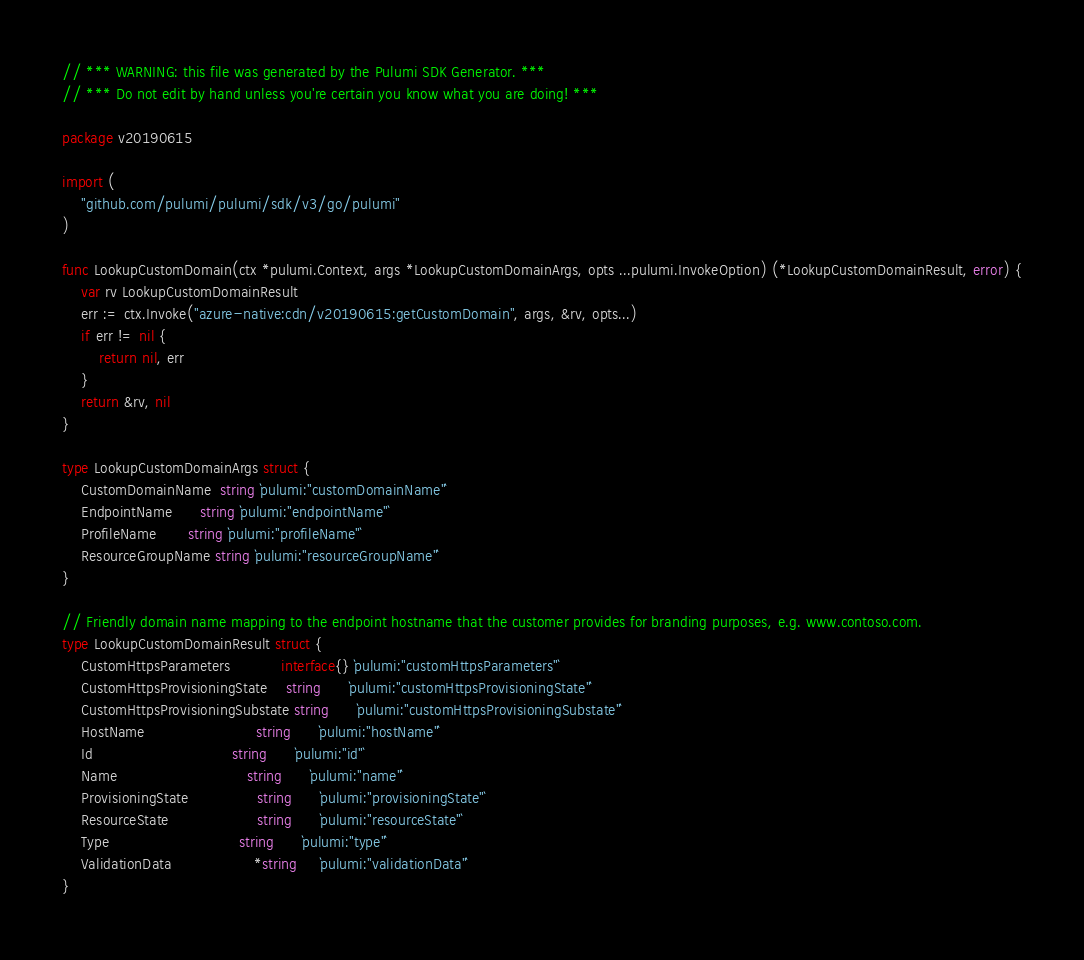Convert code to text. <code><loc_0><loc_0><loc_500><loc_500><_Go_>// *** WARNING: this file was generated by the Pulumi SDK Generator. ***
// *** Do not edit by hand unless you're certain you know what you are doing! ***

package v20190615

import (
	"github.com/pulumi/pulumi/sdk/v3/go/pulumi"
)

func LookupCustomDomain(ctx *pulumi.Context, args *LookupCustomDomainArgs, opts ...pulumi.InvokeOption) (*LookupCustomDomainResult, error) {
	var rv LookupCustomDomainResult
	err := ctx.Invoke("azure-native:cdn/v20190615:getCustomDomain", args, &rv, opts...)
	if err != nil {
		return nil, err
	}
	return &rv, nil
}

type LookupCustomDomainArgs struct {
	CustomDomainName  string `pulumi:"customDomainName"`
	EndpointName      string `pulumi:"endpointName"`
	ProfileName       string `pulumi:"profileName"`
	ResourceGroupName string `pulumi:"resourceGroupName"`
}

// Friendly domain name mapping to the endpoint hostname that the customer provides for branding purposes, e.g. www.contoso.com.
type LookupCustomDomainResult struct {
	CustomHttpsParameters           interface{} `pulumi:"customHttpsParameters"`
	CustomHttpsProvisioningState    string      `pulumi:"customHttpsProvisioningState"`
	CustomHttpsProvisioningSubstate string      `pulumi:"customHttpsProvisioningSubstate"`
	HostName                        string      `pulumi:"hostName"`
	Id                              string      `pulumi:"id"`
	Name                            string      `pulumi:"name"`
	ProvisioningState               string      `pulumi:"provisioningState"`
	ResourceState                   string      `pulumi:"resourceState"`
	Type                            string      `pulumi:"type"`
	ValidationData                  *string     `pulumi:"validationData"`
}
</code> 